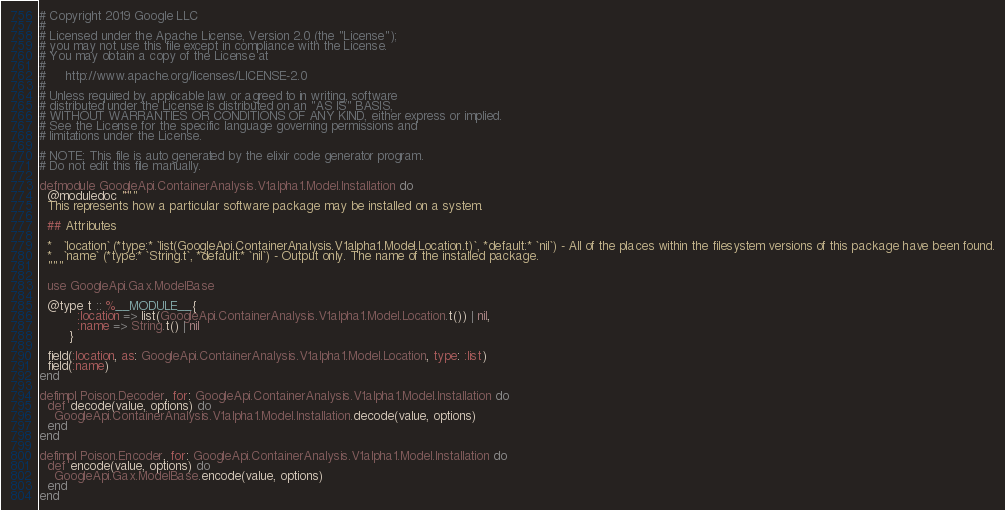Convert code to text. <code><loc_0><loc_0><loc_500><loc_500><_Elixir_># Copyright 2019 Google LLC
#
# Licensed under the Apache License, Version 2.0 (the "License");
# you may not use this file except in compliance with the License.
# You may obtain a copy of the License at
#
#     http://www.apache.org/licenses/LICENSE-2.0
#
# Unless required by applicable law or agreed to in writing, software
# distributed under the License is distributed on an "AS IS" BASIS,
# WITHOUT WARRANTIES OR CONDITIONS OF ANY KIND, either express or implied.
# See the License for the specific language governing permissions and
# limitations under the License.

# NOTE: This file is auto generated by the elixir code generator program.
# Do not edit this file manually.

defmodule GoogleApi.ContainerAnalysis.V1alpha1.Model.Installation do
  @moduledoc """
  This represents how a particular software package may be installed on a system.

  ## Attributes

  *   `location` (*type:* `list(GoogleApi.ContainerAnalysis.V1alpha1.Model.Location.t)`, *default:* `nil`) - All of the places within the filesystem versions of this package have been found.
  *   `name` (*type:* `String.t`, *default:* `nil`) - Output only. The name of the installed package.
  """

  use GoogleApi.Gax.ModelBase

  @type t :: %__MODULE__{
          :location => list(GoogleApi.ContainerAnalysis.V1alpha1.Model.Location.t()) | nil,
          :name => String.t() | nil
        }

  field(:location, as: GoogleApi.ContainerAnalysis.V1alpha1.Model.Location, type: :list)
  field(:name)
end

defimpl Poison.Decoder, for: GoogleApi.ContainerAnalysis.V1alpha1.Model.Installation do
  def decode(value, options) do
    GoogleApi.ContainerAnalysis.V1alpha1.Model.Installation.decode(value, options)
  end
end

defimpl Poison.Encoder, for: GoogleApi.ContainerAnalysis.V1alpha1.Model.Installation do
  def encode(value, options) do
    GoogleApi.Gax.ModelBase.encode(value, options)
  end
end
</code> 